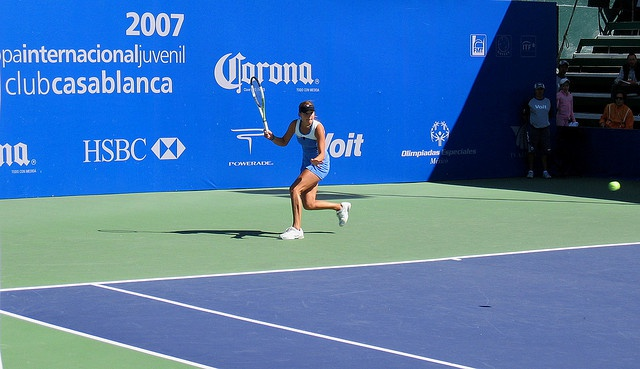Describe the objects in this image and their specific colors. I can see people in blue, black, navy, maroon, and white tones, people in blue, black, navy, darkblue, and gray tones, people in blue, black, maroon, and gray tones, people in blue, black, navy, and purple tones, and people in blue, black, darkblue, and gray tones in this image. 